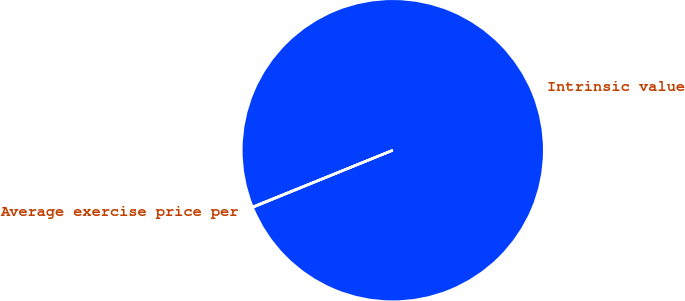<chart> <loc_0><loc_0><loc_500><loc_500><pie_chart><fcel>Intrinsic value<fcel>Average exercise price per<nl><fcel>99.95%<fcel>0.05%<nl></chart> 